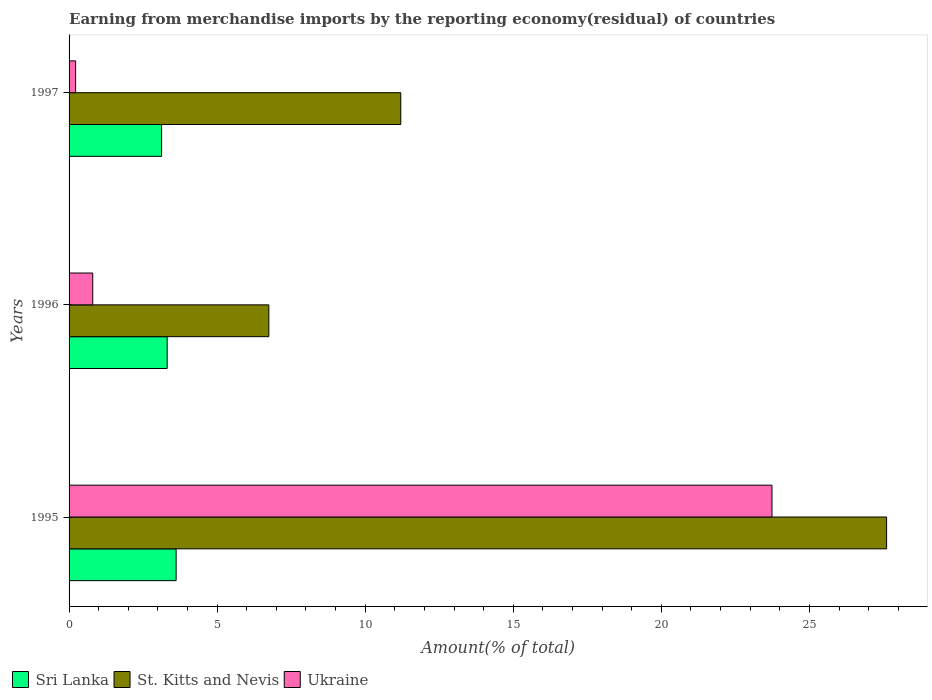How many groups of bars are there?
Your answer should be compact. 3. Are the number of bars on each tick of the Y-axis equal?
Provide a succinct answer. Yes. How many bars are there on the 3rd tick from the top?
Ensure brevity in your answer.  3. How many bars are there on the 1st tick from the bottom?
Offer a terse response. 3. What is the label of the 2nd group of bars from the top?
Provide a short and direct response. 1996. In how many cases, is the number of bars for a given year not equal to the number of legend labels?
Offer a very short reply. 0. What is the percentage of amount earned from merchandise imports in St. Kitts and Nevis in 1996?
Your response must be concise. 6.75. Across all years, what is the maximum percentage of amount earned from merchandise imports in Sri Lanka?
Offer a very short reply. 3.62. Across all years, what is the minimum percentage of amount earned from merchandise imports in St. Kitts and Nevis?
Give a very brief answer. 6.75. What is the total percentage of amount earned from merchandise imports in Sri Lanka in the graph?
Ensure brevity in your answer.  10.05. What is the difference between the percentage of amount earned from merchandise imports in St. Kitts and Nevis in 1995 and that in 1997?
Offer a terse response. 16.41. What is the difference between the percentage of amount earned from merchandise imports in Ukraine in 1996 and the percentage of amount earned from merchandise imports in St. Kitts and Nevis in 1995?
Provide a succinct answer. -26.81. What is the average percentage of amount earned from merchandise imports in Sri Lanka per year?
Provide a short and direct response. 3.35. In the year 1995, what is the difference between the percentage of amount earned from merchandise imports in Ukraine and percentage of amount earned from merchandise imports in St. Kitts and Nevis?
Your answer should be very brief. -3.87. In how many years, is the percentage of amount earned from merchandise imports in Sri Lanka greater than 8 %?
Make the answer very short. 0. What is the ratio of the percentage of amount earned from merchandise imports in Sri Lanka in 1996 to that in 1997?
Offer a very short reply. 1.06. Is the difference between the percentage of amount earned from merchandise imports in Ukraine in 1995 and 1996 greater than the difference between the percentage of amount earned from merchandise imports in St. Kitts and Nevis in 1995 and 1996?
Provide a succinct answer. Yes. What is the difference between the highest and the second highest percentage of amount earned from merchandise imports in St. Kitts and Nevis?
Your answer should be very brief. 16.41. What is the difference between the highest and the lowest percentage of amount earned from merchandise imports in Ukraine?
Provide a short and direct response. 23.51. What does the 3rd bar from the top in 1997 represents?
Your answer should be compact. Sri Lanka. What does the 1st bar from the bottom in 1995 represents?
Provide a succinct answer. Sri Lanka. How many years are there in the graph?
Provide a succinct answer. 3. Are the values on the major ticks of X-axis written in scientific E-notation?
Your answer should be very brief. No. Does the graph contain any zero values?
Provide a short and direct response. No. How many legend labels are there?
Offer a very short reply. 3. How are the legend labels stacked?
Offer a very short reply. Horizontal. What is the title of the graph?
Make the answer very short. Earning from merchandise imports by the reporting economy(residual) of countries. What is the label or title of the X-axis?
Make the answer very short. Amount(% of total). What is the label or title of the Y-axis?
Keep it short and to the point. Years. What is the Amount(% of total) in Sri Lanka in 1995?
Offer a very short reply. 3.62. What is the Amount(% of total) in St. Kitts and Nevis in 1995?
Your answer should be very brief. 27.61. What is the Amount(% of total) in Ukraine in 1995?
Ensure brevity in your answer.  23.74. What is the Amount(% of total) of Sri Lanka in 1996?
Your answer should be very brief. 3.31. What is the Amount(% of total) in St. Kitts and Nevis in 1996?
Give a very brief answer. 6.75. What is the Amount(% of total) in Ukraine in 1996?
Keep it short and to the point. 0.8. What is the Amount(% of total) of Sri Lanka in 1997?
Offer a terse response. 3.12. What is the Amount(% of total) of St. Kitts and Nevis in 1997?
Offer a terse response. 11.2. What is the Amount(% of total) of Ukraine in 1997?
Your response must be concise. 0.22. Across all years, what is the maximum Amount(% of total) in Sri Lanka?
Offer a very short reply. 3.62. Across all years, what is the maximum Amount(% of total) in St. Kitts and Nevis?
Offer a terse response. 27.61. Across all years, what is the maximum Amount(% of total) of Ukraine?
Offer a terse response. 23.74. Across all years, what is the minimum Amount(% of total) in Sri Lanka?
Make the answer very short. 3.12. Across all years, what is the minimum Amount(% of total) of St. Kitts and Nevis?
Make the answer very short. 6.75. Across all years, what is the minimum Amount(% of total) of Ukraine?
Offer a very short reply. 0.22. What is the total Amount(% of total) in Sri Lanka in the graph?
Your answer should be very brief. 10.05. What is the total Amount(% of total) of St. Kitts and Nevis in the graph?
Offer a very short reply. 45.55. What is the total Amount(% of total) in Ukraine in the graph?
Ensure brevity in your answer.  24.76. What is the difference between the Amount(% of total) in Sri Lanka in 1995 and that in 1996?
Your response must be concise. 0.3. What is the difference between the Amount(% of total) of St. Kitts and Nevis in 1995 and that in 1996?
Ensure brevity in your answer.  20.86. What is the difference between the Amount(% of total) in Ukraine in 1995 and that in 1996?
Your response must be concise. 22.94. What is the difference between the Amount(% of total) of Sri Lanka in 1995 and that in 1997?
Offer a terse response. 0.49. What is the difference between the Amount(% of total) in St. Kitts and Nevis in 1995 and that in 1997?
Provide a short and direct response. 16.41. What is the difference between the Amount(% of total) in Ukraine in 1995 and that in 1997?
Ensure brevity in your answer.  23.51. What is the difference between the Amount(% of total) of Sri Lanka in 1996 and that in 1997?
Keep it short and to the point. 0.19. What is the difference between the Amount(% of total) of St. Kitts and Nevis in 1996 and that in 1997?
Your answer should be compact. -4.45. What is the difference between the Amount(% of total) of Ukraine in 1996 and that in 1997?
Provide a short and direct response. 0.58. What is the difference between the Amount(% of total) in Sri Lanka in 1995 and the Amount(% of total) in St. Kitts and Nevis in 1996?
Provide a succinct answer. -3.13. What is the difference between the Amount(% of total) of Sri Lanka in 1995 and the Amount(% of total) of Ukraine in 1996?
Ensure brevity in your answer.  2.82. What is the difference between the Amount(% of total) in St. Kitts and Nevis in 1995 and the Amount(% of total) in Ukraine in 1996?
Provide a short and direct response. 26.81. What is the difference between the Amount(% of total) in Sri Lanka in 1995 and the Amount(% of total) in St. Kitts and Nevis in 1997?
Give a very brief answer. -7.59. What is the difference between the Amount(% of total) in Sri Lanka in 1995 and the Amount(% of total) in Ukraine in 1997?
Provide a short and direct response. 3.39. What is the difference between the Amount(% of total) of St. Kitts and Nevis in 1995 and the Amount(% of total) of Ukraine in 1997?
Ensure brevity in your answer.  27.39. What is the difference between the Amount(% of total) of Sri Lanka in 1996 and the Amount(% of total) of St. Kitts and Nevis in 1997?
Your answer should be very brief. -7.89. What is the difference between the Amount(% of total) of Sri Lanka in 1996 and the Amount(% of total) of Ukraine in 1997?
Ensure brevity in your answer.  3.09. What is the difference between the Amount(% of total) in St. Kitts and Nevis in 1996 and the Amount(% of total) in Ukraine in 1997?
Offer a very short reply. 6.52. What is the average Amount(% of total) of Sri Lanka per year?
Keep it short and to the point. 3.35. What is the average Amount(% of total) in St. Kitts and Nevis per year?
Offer a very short reply. 15.18. What is the average Amount(% of total) of Ukraine per year?
Provide a short and direct response. 8.25. In the year 1995, what is the difference between the Amount(% of total) of Sri Lanka and Amount(% of total) of St. Kitts and Nevis?
Make the answer very short. -23.99. In the year 1995, what is the difference between the Amount(% of total) of Sri Lanka and Amount(% of total) of Ukraine?
Offer a terse response. -20.12. In the year 1995, what is the difference between the Amount(% of total) in St. Kitts and Nevis and Amount(% of total) in Ukraine?
Your response must be concise. 3.87. In the year 1996, what is the difference between the Amount(% of total) of Sri Lanka and Amount(% of total) of St. Kitts and Nevis?
Offer a terse response. -3.43. In the year 1996, what is the difference between the Amount(% of total) of Sri Lanka and Amount(% of total) of Ukraine?
Provide a succinct answer. 2.51. In the year 1996, what is the difference between the Amount(% of total) of St. Kitts and Nevis and Amount(% of total) of Ukraine?
Offer a terse response. 5.95. In the year 1997, what is the difference between the Amount(% of total) of Sri Lanka and Amount(% of total) of St. Kitts and Nevis?
Provide a short and direct response. -8.08. In the year 1997, what is the difference between the Amount(% of total) in Sri Lanka and Amount(% of total) in Ukraine?
Offer a very short reply. 2.9. In the year 1997, what is the difference between the Amount(% of total) of St. Kitts and Nevis and Amount(% of total) of Ukraine?
Make the answer very short. 10.98. What is the ratio of the Amount(% of total) of Sri Lanka in 1995 to that in 1996?
Your answer should be compact. 1.09. What is the ratio of the Amount(% of total) in St. Kitts and Nevis in 1995 to that in 1996?
Keep it short and to the point. 4.09. What is the ratio of the Amount(% of total) of Ukraine in 1995 to that in 1996?
Your answer should be compact. 29.69. What is the ratio of the Amount(% of total) of Sri Lanka in 1995 to that in 1997?
Offer a very short reply. 1.16. What is the ratio of the Amount(% of total) in St. Kitts and Nevis in 1995 to that in 1997?
Give a very brief answer. 2.46. What is the ratio of the Amount(% of total) of Ukraine in 1995 to that in 1997?
Provide a short and direct response. 107.18. What is the ratio of the Amount(% of total) in Sri Lanka in 1996 to that in 1997?
Your response must be concise. 1.06. What is the ratio of the Amount(% of total) of St. Kitts and Nevis in 1996 to that in 1997?
Your answer should be very brief. 0.6. What is the ratio of the Amount(% of total) in Ukraine in 1996 to that in 1997?
Offer a terse response. 3.61. What is the difference between the highest and the second highest Amount(% of total) in Sri Lanka?
Keep it short and to the point. 0.3. What is the difference between the highest and the second highest Amount(% of total) in St. Kitts and Nevis?
Your answer should be compact. 16.41. What is the difference between the highest and the second highest Amount(% of total) in Ukraine?
Offer a very short reply. 22.94. What is the difference between the highest and the lowest Amount(% of total) in Sri Lanka?
Your answer should be compact. 0.49. What is the difference between the highest and the lowest Amount(% of total) in St. Kitts and Nevis?
Offer a very short reply. 20.86. What is the difference between the highest and the lowest Amount(% of total) in Ukraine?
Your answer should be very brief. 23.51. 